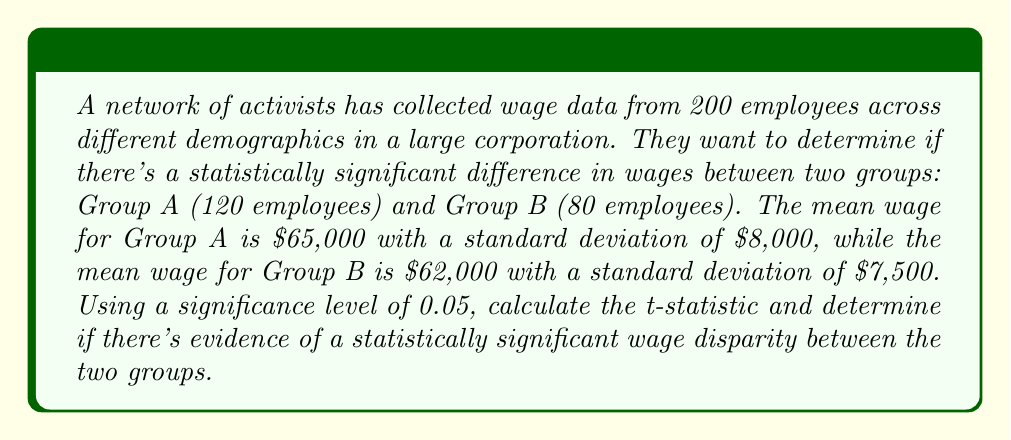Solve this math problem. To determine if there's a statistically significant difference in wages between the two groups, we'll use a two-sample t-test. Here's the step-by-step process:

1. State the null and alternative hypotheses:
   $H_0: \mu_A - \mu_B = 0$ (no difference in mean wages)
   $H_a: \mu_A - \mu_B \neq 0$ (there is a difference in mean wages)

2. Calculate the pooled standard error:
   $$SE = \sqrt{\frac{s_A^2}{n_A} + \frac{s_B^2}{n_B}}$$
   Where:
   $s_A$ and $s_B$ are the standard deviations of Group A and B
   $n_A$ and $n_B$ are the sample sizes of Group A and B

   $$SE = \sqrt{\frac{8000^2}{120} + \frac{7500^2}{80}} = \sqrt{533333.33 + 703125} = \sqrt{1236458.33} \approx 1112.01$$

3. Calculate the t-statistic:
   $$t = \frac{(\bar{x}_A - \bar{x}_B) - (\mu_A - \mu_B)}{SE}$$
   Where $\bar{x}_A$ and $\bar{x}_B$ are the sample means, and $(\mu_A - \mu_B) = 0$ under the null hypothesis

   $$t = \frac{(65000 - 62000) - 0}{1112.01} \approx 2.70$$

4. Determine the degrees of freedom:
   $$df = n_A + n_B - 2 = 120 + 80 - 2 = 198$$

5. Find the critical t-value for a two-tailed test at α = 0.05 and df = 198:
   The critical t-value is approximately ±1.97

6. Compare the calculated t-statistic to the critical t-value:
   Since |2.70| > 1.97, we reject the null hypothesis.

7. Calculate the p-value:
   Using a t-distribution calculator or table, we find that the p-value for t ≈ 2.70 with df = 198 is approximately 0.0075.
Answer: The calculated t-statistic is approximately 2.70, which is greater than the critical value of 1.97. Additionally, the p-value (0.0075) is less than the significance level (0.05). Therefore, we reject the null hypothesis and conclude that there is statistically significant evidence of a wage disparity between Group A and Group B at the 0.05 significance level. 